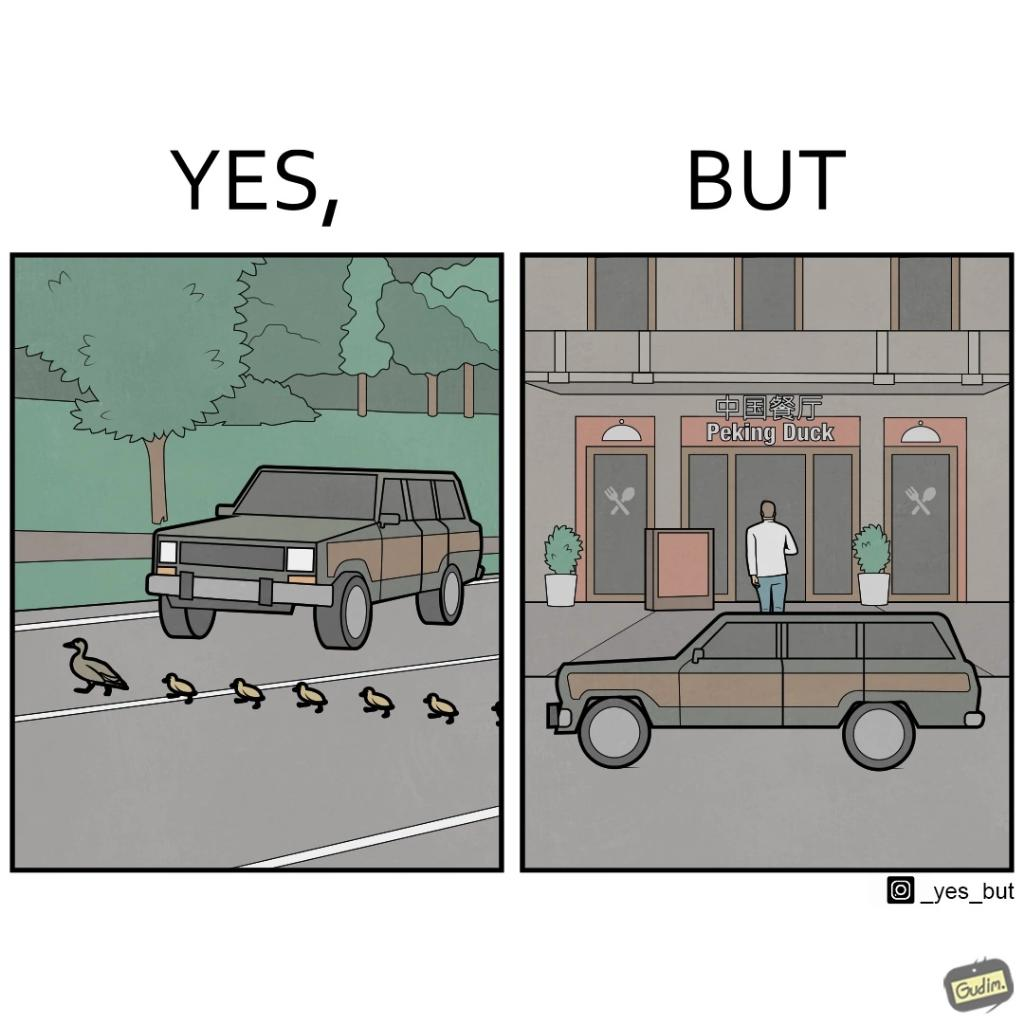Describe what you see in this image. The images are ironic since they show how a man supposedly cares for ducks since he stops his vehicle to give way to queue of ducks allowing them to safely cross a road but on the other hand he goes to a peking duck shop to buy and eat similar ducks after having them killed 